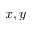<formula> <loc_0><loc_0><loc_500><loc_500>x , y</formula> 